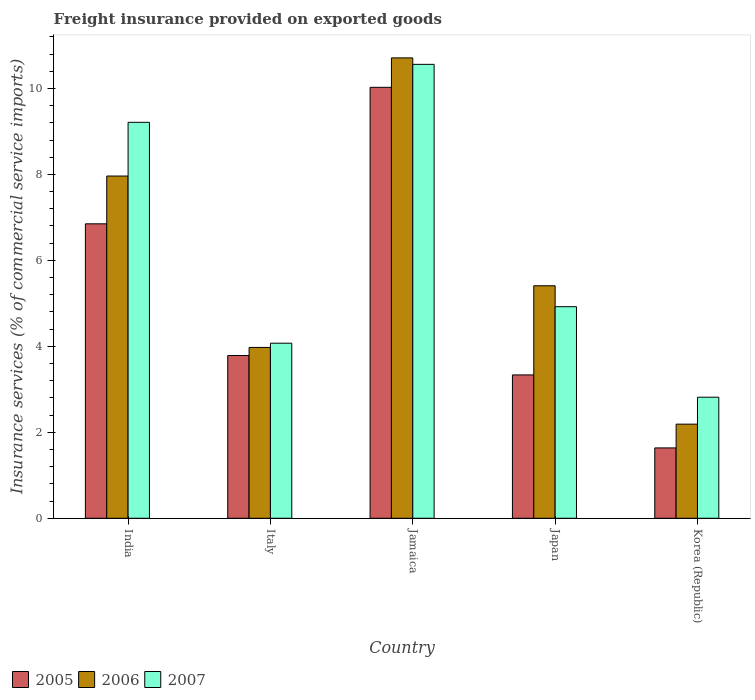How many different coloured bars are there?
Your answer should be very brief. 3. Are the number of bars per tick equal to the number of legend labels?
Provide a short and direct response. Yes. Are the number of bars on each tick of the X-axis equal?
Offer a terse response. Yes. What is the label of the 4th group of bars from the left?
Provide a short and direct response. Japan. What is the freight insurance provided on exported goods in 2007 in Italy?
Keep it short and to the point. 4.07. Across all countries, what is the maximum freight insurance provided on exported goods in 2005?
Provide a short and direct response. 10.03. Across all countries, what is the minimum freight insurance provided on exported goods in 2005?
Your answer should be very brief. 1.64. In which country was the freight insurance provided on exported goods in 2007 maximum?
Give a very brief answer. Jamaica. In which country was the freight insurance provided on exported goods in 2006 minimum?
Your answer should be compact. Korea (Republic). What is the total freight insurance provided on exported goods in 2007 in the graph?
Ensure brevity in your answer.  31.58. What is the difference between the freight insurance provided on exported goods in 2006 in Italy and that in Korea (Republic)?
Offer a very short reply. 1.78. What is the difference between the freight insurance provided on exported goods in 2005 in Japan and the freight insurance provided on exported goods in 2006 in Korea (Republic)?
Give a very brief answer. 1.15. What is the average freight insurance provided on exported goods in 2006 per country?
Offer a very short reply. 6.05. What is the difference between the freight insurance provided on exported goods of/in 2007 and freight insurance provided on exported goods of/in 2006 in Jamaica?
Ensure brevity in your answer.  -0.15. What is the ratio of the freight insurance provided on exported goods in 2005 in India to that in Japan?
Give a very brief answer. 2.05. Is the difference between the freight insurance provided on exported goods in 2007 in Italy and Japan greater than the difference between the freight insurance provided on exported goods in 2006 in Italy and Japan?
Give a very brief answer. Yes. What is the difference between the highest and the second highest freight insurance provided on exported goods in 2005?
Your response must be concise. 6.24. What is the difference between the highest and the lowest freight insurance provided on exported goods in 2005?
Your answer should be very brief. 8.39. Is it the case that in every country, the sum of the freight insurance provided on exported goods in 2005 and freight insurance provided on exported goods in 2006 is greater than the freight insurance provided on exported goods in 2007?
Offer a very short reply. Yes. How many bars are there?
Your response must be concise. 15. Are the values on the major ticks of Y-axis written in scientific E-notation?
Give a very brief answer. No. Does the graph contain any zero values?
Offer a very short reply. No. Does the graph contain grids?
Keep it short and to the point. No. Where does the legend appear in the graph?
Your answer should be very brief. Bottom left. How are the legend labels stacked?
Your answer should be compact. Horizontal. What is the title of the graph?
Your answer should be very brief. Freight insurance provided on exported goods. Does "1997" appear as one of the legend labels in the graph?
Your answer should be compact. No. What is the label or title of the Y-axis?
Offer a very short reply. Insurance services (% of commercial service imports). What is the Insurance services (% of commercial service imports) in 2005 in India?
Your answer should be compact. 6.85. What is the Insurance services (% of commercial service imports) of 2006 in India?
Give a very brief answer. 7.96. What is the Insurance services (% of commercial service imports) in 2007 in India?
Provide a succinct answer. 9.21. What is the Insurance services (% of commercial service imports) in 2005 in Italy?
Provide a short and direct response. 3.79. What is the Insurance services (% of commercial service imports) in 2006 in Italy?
Your answer should be compact. 3.97. What is the Insurance services (% of commercial service imports) in 2007 in Italy?
Your response must be concise. 4.07. What is the Insurance services (% of commercial service imports) of 2005 in Jamaica?
Provide a succinct answer. 10.03. What is the Insurance services (% of commercial service imports) of 2006 in Jamaica?
Offer a terse response. 10.71. What is the Insurance services (% of commercial service imports) in 2007 in Jamaica?
Offer a terse response. 10.56. What is the Insurance services (% of commercial service imports) in 2005 in Japan?
Provide a short and direct response. 3.34. What is the Insurance services (% of commercial service imports) of 2006 in Japan?
Ensure brevity in your answer.  5.41. What is the Insurance services (% of commercial service imports) in 2007 in Japan?
Give a very brief answer. 4.92. What is the Insurance services (% of commercial service imports) in 2005 in Korea (Republic)?
Make the answer very short. 1.64. What is the Insurance services (% of commercial service imports) of 2006 in Korea (Republic)?
Your response must be concise. 2.19. What is the Insurance services (% of commercial service imports) in 2007 in Korea (Republic)?
Your answer should be compact. 2.82. Across all countries, what is the maximum Insurance services (% of commercial service imports) of 2005?
Your answer should be compact. 10.03. Across all countries, what is the maximum Insurance services (% of commercial service imports) of 2006?
Ensure brevity in your answer.  10.71. Across all countries, what is the maximum Insurance services (% of commercial service imports) of 2007?
Ensure brevity in your answer.  10.56. Across all countries, what is the minimum Insurance services (% of commercial service imports) in 2005?
Offer a terse response. 1.64. Across all countries, what is the minimum Insurance services (% of commercial service imports) in 2006?
Your answer should be very brief. 2.19. Across all countries, what is the minimum Insurance services (% of commercial service imports) of 2007?
Offer a very short reply. 2.82. What is the total Insurance services (% of commercial service imports) in 2005 in the graph?
Ensure brevity in your answer.  25.63. What is the total Insurance services (% of commercial service imports) of 2006 in the graph?
Your answer should be compact. 30.25. What is the total Insurance services (% of commercial service imports) of 2007 in the graph?
Make the answer very short. 31.58. What is the difference between the Insurance services (% of commercial service imports) of 2005 in India and that in Italy?
Offer a very short reply. 3.06. What is the difference between the Insurance services (% of commercial service imports) in 2006 in India and that in Italy?
Your response must be concise. 3.99. What is the difference between the Insurance services (% of commercial service imports) in 2007 in India and that in Italy?
Your answer should be very brief. 5.14. What is the difference between the Insurance services (% of commercial service imports) of 2005 in India and that in Jamaica?
Provide a succinct answer. -3.18. What is the difference between the Insurance services (% of commercial service imports) of 2006 in India and that in Jamaica?
Provide a short and direct response. -2.75. What is the difference between the Insurance services (% of commercial service imports) of 2007 in India and that in Jamaica?
Keep it short and to the point. -1.35. What is the difference between the Insurance services (% of commercial service imports) in 2005 in India and that in Japan?
Ensure brevity in your answer.  3.52. What is the difference between the Insurance services (% of commercial service imports) of 2006 in India and that in Japan?
Give a very brief answer. 2.55. What is the difference between the Insurance services (% of commercial service imports) in 2007 in India and that in Japan?
Your response must be concise. 4.29. What is the difference between the Insurance services (% of commercial service imports) in 2005 in India and that in Korea (Republic)?
Give a very brief answer. 5.21. What is the difference between the Insurance services (% of commercial service imports) in 2006 in India and that in Korea (Republic)?
Make the answer very short. 5.77. What is the difference between the Insurance services (% of commercial service imports) of 2007 in India and that in Korea (Republic)?
Ensure brevity in your answer.  6.4. What is the difference between the Insurance services (% of commercial service imports) in 2005 in Italy and that in Jamaica?
Give a very brief answer. -6.24. What is the difference between the Insurance services (% of commercial service imports) of 2006 in Italy and that in Jamaica?
Give a very brief answer. -6.74. What is the difference between the Insurance services (% of commercial service imports) of 2007 in Italy and that in Jamaica?
Offer a terse response. -6.49. What is the difference between the Insurance services (% of commercial service imports) of 2005 in Italy and that in Japan?
Keep it short and to the point. 0.45. What is the difference between the Insurance services (% of commercial service imports) of 2006 in Italy and that in Japan?
Keep it short and to the point. -1.43. What is the difference between the Insurance services (% of commercial service imports) in 2007 in Italy and that in Japan?
Your answer should be compact. -0.85. What is the difference between the Insurance services (% of commercial service imports) in 2005 in Italy and that in Korea (Republic)?
Ensure brevity in your answer.  2.15. What is the difference between the Insurance services (% of commercial service imports) of 2006 in Italy and that in Korea (Republic)?
Ensure brevity in your answer.  1.78. What is the difference between the Insurance services (% of commercial service imports) in 2007 in Italy and that in Korea (Republic)?
Your answer should be compact. 1.26. What is the difference between the Insurance services (% of commercial service imports) in 2005 in Jamaica and that in Japan?
Your answer should be compact. 6.69. What is the difference between the Insurance services (% of commercial service imports) of 2006 in Jamaica and that in Japan?
Your answer should be very brief. 5.3. What is the difference between the Insurance services (% of commercial service imports) in 2007 in Jamaica and that in Japan?
Give a very brief answer. 5.64. What is the difference between the Insurance services (% of commercial service imports) in 2005 in Jamaica and that in Korea (Republic)?
Give a very brief answer. 8.39. What is the difference between the Insurance services (% of commercial service imports) in 2006 in Jamaica and that in Korea (Republic)?
Ensure brevity in your answer.  8.52. What is the difference between the Insurance services (% of commercial service imports) in 2007 in Jamaica and that in Korea (Republic)?
Your answer should be very brief. 7.74. What is the difference between the Insurance services (% of commercial service imports) of 2005 in Japan and that in Korea (Republic)?
Make the answer very short. 1.7. What is the difference between the Insurance services (% of commercial service imports) of 2006 in Japan and that in Korea (Republic)?
Make the answer very short. 3.22. What is the difference between the Insurance services (% of commercial service imports) in 2007 in Japan and that in Korea (Republic)?
Keep it short and to the point. 2.11. What is the difference between the Insurance services (% of commercial service imports) of 2005 in India and the Insurance services (% of commercial service imports) of 2006 in Italy?
Provide a short and direct response. 2.88. What is the difference between the Insurance services (% of commercial service imports) of 2005 in India and the Insurance services (% of commercial service imports) of 2007 in Italy?
Keep it short and to the point. 2.78. What is the difference between the Insurance services (% of commercial service imports) of 2006 in India and the Insurance services (% of commercial service imports) of 2007 in Italy?
Your answer should be very brief. 3.89. What is the difference between the Insurance services (% of commercial service imports) in 2005 in India and the Insurance services (% of commercial service imports) in 2006 in Jamaica?
Provide a short and direct response. -3.86. What is the difference between the Insurance services (% of commercial service imports) in 2005 in India and the Insurance services (% of commercial service imports) in 2007 in Jamaica?
Your answer should be compact. -3.71. What is the difference between the Insurance services (% of commercial service imports) of 2006 in India and the Insurance services (% of commercial service imports) of 2007 in Jamaica?
Ensure brevity in your answer.  -2.6. What is the difference between the Insurance services (% of commercial service imports) of 2005 in India and the Insurance services (% of commercial service imports) of 2006 in Japan?
Provide a short and direct response. 1.44. What is the difference between the Insurance services (% of commercial service imports) in 2005 in India and the Insurance services (% of commercial service imports) in 2007 in Japan?
Your answer should be compact. 1.93. What is the difference between the Insurance services (% of commercial service imports) in 2006 in India and the Insurance services (% of commercial service imports) in 2007 in Japan?
Keep it short and to the point. 3.04. What is the difference between the Insurance services (% of commercial service imports) of 2005 in India and the Insurance services (% of commercial service imports) of 2006 in Korea (Republic)?
Offer a very short reply. 4.66. What is the difference between the Insurance services (% of commercial service imports) of 2005 in India and the Insurance services (% of commercial service imports) of 2007 in Korea (Republic)?
Offer a very short reply. 4.03. What is the difference between the Insurance services (% of commercial service imports) in 2006 in India and the Insurance services (% of commercial service imports) in 2007 in Korea (Republic)?
Your answer should be very brief. 5.15. What is the difference between the Insurance services (% of commercial service imports) of 2005 in Italy and the Insurance services (% of commercial service imports) of 2006 in Jamaica?
Provide a succinct answer. -6.92. What is the difference between the Insurance services (% of commercial service imports) in 2005 in Italy and the Insurance services (% of commercial service imports) in 2007 in Jamaica?
Keep it short and to the point. -6.77. What is the difference between the Insurance services (% of commercial service imports) of 2006 in Italy and the Insurance services (% of commercial service imports) of 2007 in Jamaica?
Your answer should be very brief. -6.59. What is the difference between the Insurance services (% of commercial service imports) of 2005 in Italy and the Insurance services (% of commercial service imports) of 2006 in Japan?
Keep it short and to the point. -1.62. What is the difference between the Insurance services (% of commercial service imports) of 2005 in Italy and the Insurance services (% of commercial service imports) of 2007 in Japan?
Your answer should be very brief. -1.14. What is the difference between the Insurance services (% of commercial service imports) in 2006 in Italy and the Insurance services (% of commercial service imports) in 2007 in Japan?
Your answer should be very brief. -0.95. What is the difference between the Insurance services (% of commercial service imports) in 2005 in Italy and the Insurance services (% of commercial service imports) in 2006 in Korea (Republic)?
Keep it short and to the point. 1.6. What is the difference between the Insurance services (% of commercial service imports) in 2005 in Italy and the Insurance services (% of commercial service imports) in 2007 in Korea (Republic)?
Ensure brevity in your answer.  0.97. What is the difference between the Insurance services (% of commercial service imports) in 2006 in Italy and the Insurance services (% of commercial service imports) in 2007 in Korea (Republic)?
Offer a terse response. 1.16. What is the difference between the Insurance services (% of commercial service imports) in 2005 in Jamaica and the Insurance services (% of commercial service imports) in 2006 in Japan?
Provide a succinct answer. 4.62. What is the difference between the Insurance services (% of commercial service imports) in 2005 in Jamaica and the Insurance services (% of commercial service imports) in 2007 in Japan?
Provide a succinct answer. 5.1. What is the difference between the Insurance services (% of commercial service imports) in 2006 in Jamaica and the Insurance services (% of commercial service imports) in 2007 in Japan?
Offer a very short reply. 5.79. What is the difference between the Insurance services (% of commercial service imports) of 2005 in Jamaica and the Insurance services (% of commercial service imports) of 2006 in Korea (Republic)?
Offer a terse response. 7.84. What is the difference between the Insurance services (% of commercial service imports) in 2005 in Jamaica and the Insurance services (% of commercial service imports) in 2007 in Korea (Republic)?
Provide a short and direct response. 7.21. What is the difference between the Insurance services (% of commercial service imports) in 2006 in Jamaica and the Insurance services (% of commercial service imports) in 2007 in Korea (Republic)?
Provide a succinct answer. 7.89. What is the difference between the Insurance services (% of commercial service imports) of 2005 in Japan and the Insurance services (% of commercial service imports) of 2006 in Korea (Republic)?
Keep it short and to the point. 1.15. What is the difference between the Insurance services (% of commercial service imports) in 2005 in Japan and the Insurance services (% of commercial service imports) in 2007 in Korea (Republic)?
Your response must be concise. 0.52. What is the difference between the Insurance services (% of commercial service imports) of 2006 in Japan and the Insurance services (% of commercial service imports) of 2007 in Korea (Republic)?
Your answer should be very brief. 2.59. What is the average Insurance services (% of commercial service imports) in 2005 per country?
Your answer should be very brief. 5.13. What is the average Insurance services (% of commercial service imports) of 2006 per country?
Your answer should be compact. 6.05. What is the average Insurance services (% of commercial service imports) in 2007 per country?
Your answer should be very brief. 6.32. What is the difference between the Insurance services (% of commercial service imports) of 2005 and Insurance services (% of commercial service imports) of 2006 in India?
Offer a terse response. -1.11. What is the difference between the Insurance services (% of commercial service imports) in 2005 and Insurance services (% of commercial service imports) in 2007 in India?
Offer a very short reply. -2.36. What is the difference between the Insurance services (% of commercial service imports) in 2006 and Insurance services (% of commercial service imports) in 2007 in India?
Provide a succinct answer. -1.25. What is the difference between the Insurance services (% of commercial service imports) of 2005 and Insurance services (% of commercial service imports) of 2006 in Italy?
Provide a succinct answer. -0.19. What is the difference between the Insurance services (% of commercial service imports) in 2005 and Insurance services (% of commercial service imports) in 2007 in Italy?
Ensure brevity in your answer.  -0.29. What is the difference between the Insurance services (% of commercial service imports) of 2006 and Insurance services (% of commercial service imports) of 2007 in Italy?
Make the answer very short. -0.1. What is the difference between the Insurance services (% of commercial service imports) of 2005 and Insurance services (% of commercial service imports) of 2006 in Jamaica?
Make the answer very short. -0.68. What is the difference between the Insurance services (% of commercial service imports) of 2005 and Insurance services (% of commercial service imports) of 2007 in Jamaica?
Your response must be concise. -0.53. What is the difference between the Insurance services (% of commercial service imports) in 2006 and Insurance services (% of commercial service imports) in 2007 in Jamaica?
Offer a terse response. 0.15. What is the difference between the Insurance services (% of commercial service imports) of 2005 and Insurance services (% of commercial service imports) of 2006 in Japan?
Ensure brevity in your answer.  -2.07. What is the difference between the Insurance services (% of commercial service imports) of 2005 and Insurance services (% of commercial service imports) of 2007 in Japan?
Your response must be concise. -1.59. What is the difference between the Insurance services (% of commercial service imports) of 2006 and Insurance services (% of commercial service imports) of 2007 in Japan?
Ensure brevity in your answer.  0.49. What is the difference between the Insurance services (% of commercial service imports) in 2005 and Insurance services (% of commercial service imports) in 2006 in Korea (Republic)?
Give a very brief answer. -0.55. What is the difference between the Insurance services (% of commercial service imports) of 2005 and Insurance services (% of commercial service imports) of 2007 in Korea (Republic)?
Provide a short and direct response. -1.18. What is the difference between the Insurance services (% of commercial service imports) of 2006 and Insurance services (% of commercial service imports) of 2007 in Korea (Republic)?
Provide a succinct answer. -0.63. What is the ratio of the Insurance services (% of commercial service imports) of 2005 in India to that in Italy?
Your answer should be very brief. 1.81. What is the ratio of the Insurance services (% of commercial service imports) of 2006 in India to that in Italy?
Ensure brevity in your answer.  2. What is the ratio of the Insurance services (% of commercial service imports) of 2007 in India to that in Italy?
Provide a short and direct response. 2.26. What is the ratio of the Insurance services (% of commercial service imports) in 2005 in India to that in Jamaica?
Make the answer very short. 0.68. What is the ratio of the Insurance services (% of commercial service imports) in 2006 in India to that in Jamaica?
Your answer should be very brief. 0.74. What is the ratio of the Insurance services (% of commercial service imports) of 2007 in India to that in Jamaica?
Offer a terse response. 0.87. What is the ratio of the Insurance services (% of commercial service imports) in 2005 in India to that in Japan?
Make the answer very short. 2.05. What is the ratio of the Insurance services (% of commercial service imports) in 2006 in India to that in Japan?
Your answer should be compact. 1.47. What is the ratio of the Insurance services (% of commercial service imports) in 2007 in India to that in Japan?
Keep it short and to the point. 1.87. What is the ratio of the Insurance services (% of commercial service imports) of 2005 in India to that in Korea (Republic)?
Your answer should be compact. 4.19. What is the ratio of the Insurance services (% of commercial service imports) of 2006 in India to that in Korea (Republic)?
Offer a terse response. 3.64. What is the ratio of the Insurance services (% of commercial service imports) in 2007 in India to that in Korea (Republic)?
Keep it short and to the point. 3.27. What is the ratio of the Insurance services (% of commercial service imports) in 2005 in Italy to that in Jamaica?
Offer a terse response. 0.38. What is the ratio of the Insurance services (% of commercial service imports) in 2006 in Italy to that in Jamaica?
Your answer should be very brief. 0.37. What is the ratio of the Insurance services (% of commercial service imports) in 2007 in Italy to that in Jamaica?
Keep it short and to the point. 0.39. What is the ratio of the Insurance services (% of commercial service imports) of 2005 in Italy to that in Japan?
Your answer should be compact. 1.14. What is the ratio of the Insurance services (% of commercial service imports) of 2006 in Italy to that in Japan?
Make the answer very short. 0.73. What is the ratio of the Insurance services (% of commercial service imports) in 2007 in Italy to that in Japan?
Your answer should be very brief. 0.83. What is the ratio of the Insurance services (% of commercial service imports) in 2005 in Italy to that in Korea (Republic)?
Your response must be concise. 2.31. What is the ratio of the Insurance services (% of commercial service imports) in 2006 in Italy to that in Korea (Republic)?
Provide a short and direct response. 1.82. What is the ratio of the Insurance services (% of commercial service imports) of 2007 in Italy to that in Korea (Republic)?
Provide a short and direct response. 1.45. What is the ratio of the Insurance services (% of commercial service imports) in 2005 in Jamaica to that in Japan?
Ensure brevity in your answer.  3.01. What is the ratio of the Insurance services (% of commercial service imports) in 2006 in Jamaica to that in Japan?
Give a very brief answer. 1.98. What is the ratio of the Insurance services (% of commercial service imports) of 2007 in Jamaica to that in Japan?
Ensure brevity in your answer.  2.15. What is the ratio of the Insurance services (% of commercial service imports) in 2005 in Jamaica to that in Korea (Republic)?
Make the answer very short. 6.13. What is the ratio of the Insurance services (% of commercial service imports) in 2006 in Jamaica to that in Korea (Republic)?
Give a very brief answer. 4.89. What is the ratio of the Insurance services (% of commercial service imports) in 2007 in Jamaica to that in Korea (Republic)?
Offer a very short reply. 3.75. What is the ratio of the Insurance services (% of commercial service imports) in 2005 in Japan to that in Korea (Republic)?
Provide a short and direct response. 2.04. What is the ratio of the Insurance services (% of commercial service imports) in 2006 in Japan to that in Korea (Republic)?
Your answer should be compact. 2.47. What is the ratio of the Insurance services (% of commercial service imports) in 2007 in Japan to that in Korea (Republic)?
Your answer should be compact. 1.75. What is the difference between the highest and the second highest Insurance services (% of commercial service imports) of 2005?
Provide a short and direct response. 3.18. What is the difference between the highest and the second highest Insurance services (% of commercial service imports) in 2006?
Make the answer very short. 2.75. What is the difference between the highest and the second highest Insurance services (% of commercial service imports) of 2007?
Keep it short and to the point. 1.35. What is the difference between the highest and the lowest Insurance services (% of commercial service imports) in 2005?
Give a very brief answer. 8.39. What is the difference between the highest and the lowest Insurance services (% of commercial service imports) in 2006?
Provide a succinct answer. 8.52. What is the difference between the highest and the lowest Insurance services (% of commercial service imports) of 2007?
Keep it short and to the point. 7.74. 